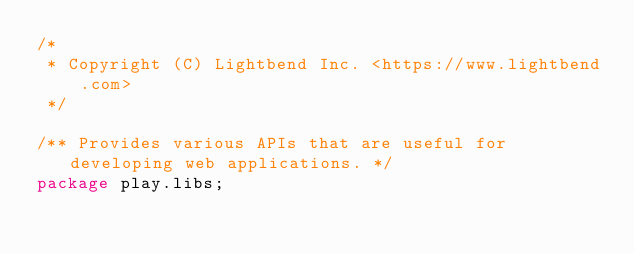<code> <loc_0><loc_0><loc_500><loc_500><_Java_>/*
 * Copyright (C) Lightbend Inc. <https://www.lightbend.com>
 */

/** Provides various APIs that are useful for developing web applications. */
package play.libs;
</code> 